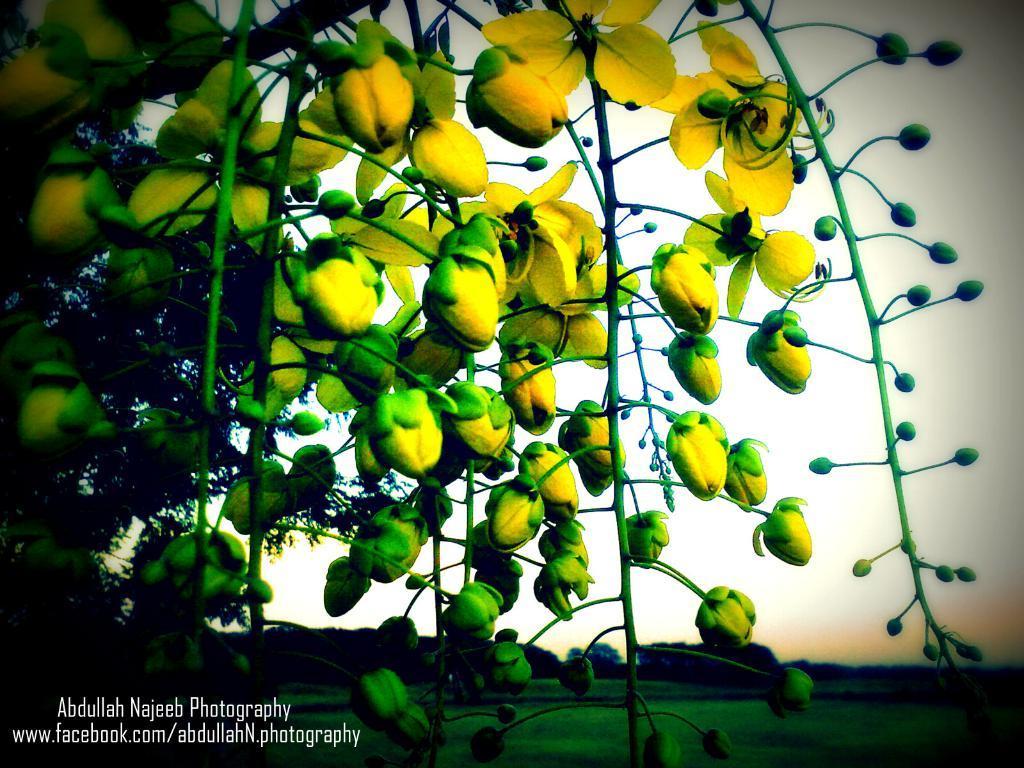Can you describe this image briefly? This is an edited picture. In this image there are yellow colour flowers and buds on the tree. At the back there are trees. At the top there is sky. At the bottom there is grass. At the bottom left there is text. 